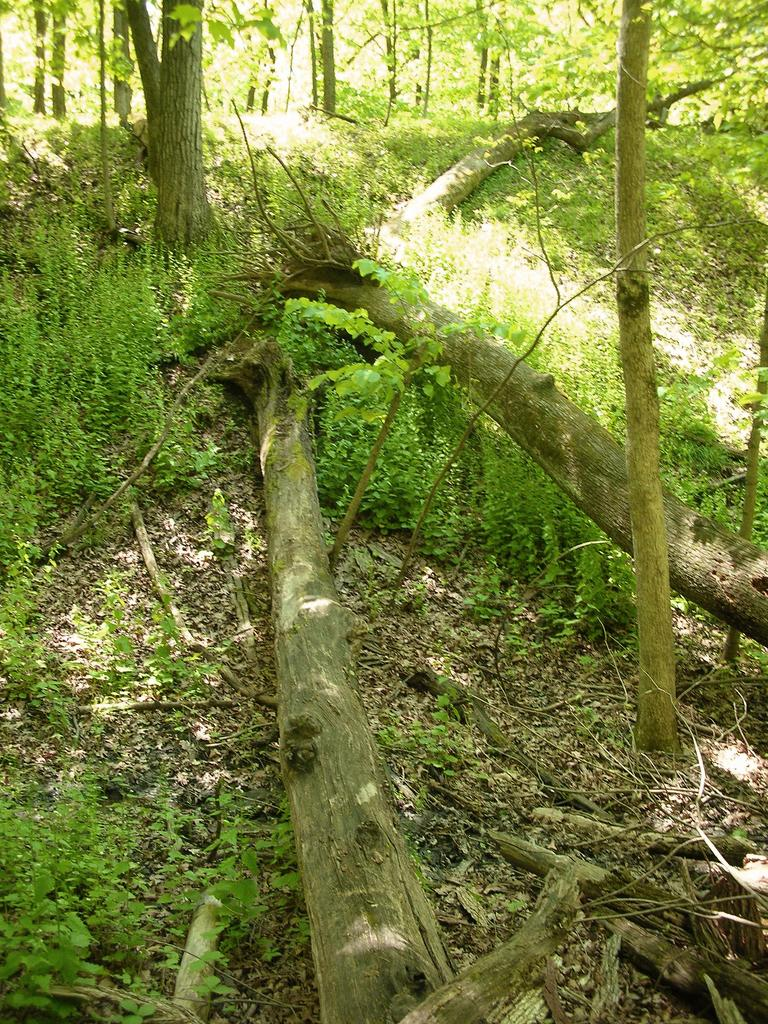What type of natural material can be seen on the ground in the image? There are fallen tree bark in the image. What type of large vegetation is present in the image? There are trees in the image. What type of smaller vegetation is present in the image? There are plants in the image. What type of plant material is present on the land in the image? Dried leaves are present on the land in the image. How many times has the tree been divided in the image? There is no indication of any division or splitting of the tree in the image. What type of caption is present in the image? There is no caption present in the image; it is a photograph of natural elements. 